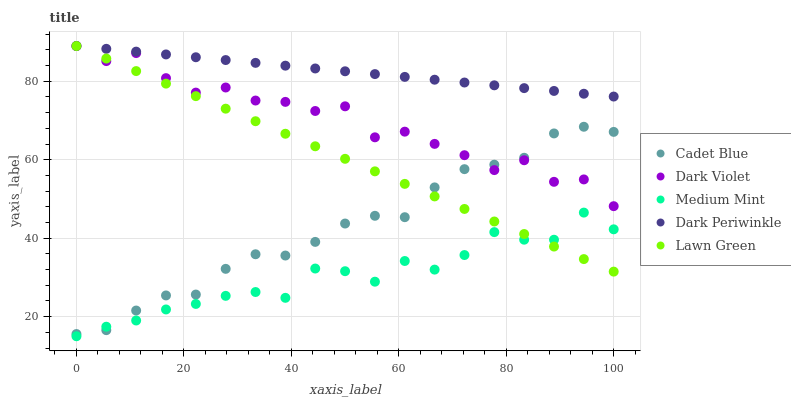Does Medium Mint have the minimum area under the curve?
Answer yes or no. Yes. Does Dark Periwinkle have the maximum area under the curve?
Answer yes or no. Yes. Does Lawn Green have the minimum area under the curve?
Answer yes or no. No. Does Lawn Green have the maximum area under the curve?
Answer yes or no. No. Is Lawn Green the smoothest?
Answer yes or no. Yes. Is Dark Violet the roughest?
Answer yes or no. Yes. Is Cadet Blue the smoothest?
Answer yes or no. No. Is Cadet Blue the roughest?
Answer yes or no. No. Does Medium Mint have the lowest value?
Answer yes or no. Yes. Does Lawn Green have the lowest value?
Answer yes or no. No. Does Dark Violet have the highest value?
Answer yes or no. Yes. Does Cadet Blue have the highest value?
Answer yes or no. No. Is Medium Mint less than Dark Periwinkle?
Answer yes or no. Yes. Is Dark Periwinkle greater than Cadet Blue?
Answer yes or no. Yes. Does Cadet Blue intersect Dark Violet?
Answer yes or no. Yes. Is Cadet Blue less than Dark Violet?
Answer yes or no. No. Is Cadet Blue greater than Dark Violet?
Answer yes or no. No. Does Medium Mint intersect Dark Periwinkle?
Answer yes or no. No. 